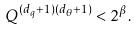Convert formula to latex. <formula><loc_0><loc_0><loc_500><loc_500>Q ^ { ( d _ { q } + 1 ) ( d _ { \theta } + 1 ) } < 2 ^ { \beta } .</formula> 